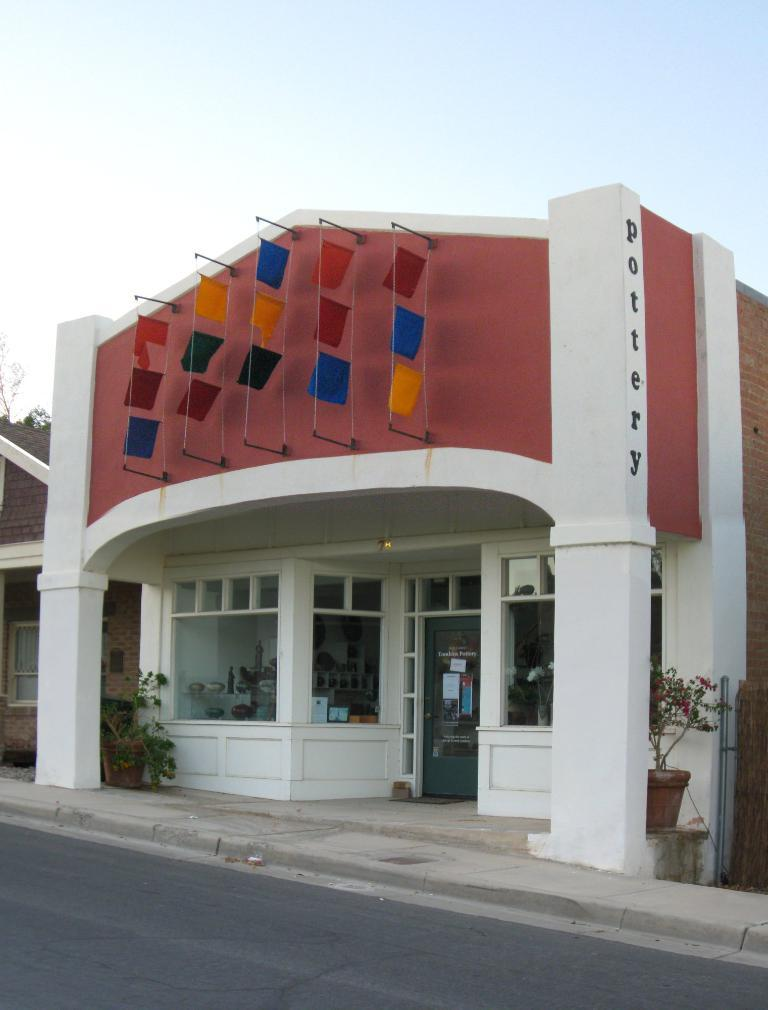What type of structure is present in the image? There is a building in the image. What architectural feature can be seen on the building? The building has pillars. What else is visible in the image besides the building? There is a plant pot and a road in the image. What can be seen in the background of the image? The sky is visible in the image. How many clams are sitting on the pillars of the building in the image? There are no clams present in the image; the building has pillars, but they are not occupied by clams. 